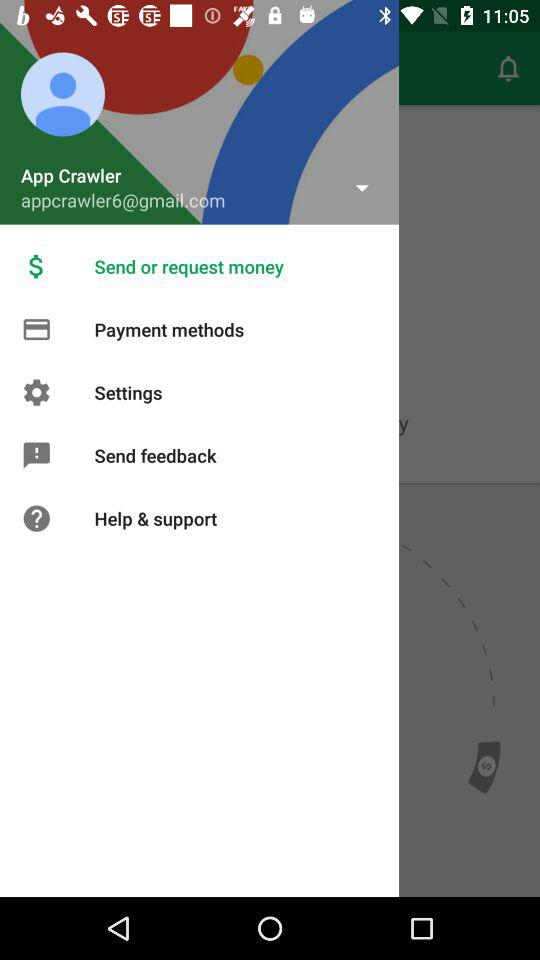What is the name of the user? The name of the user is App Crawler. 